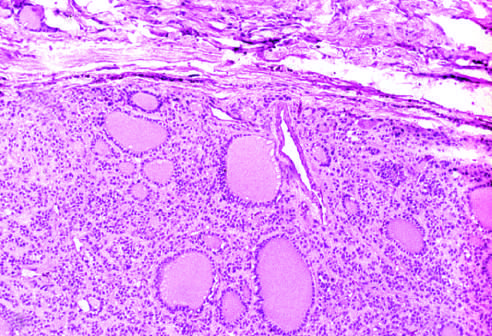does a fibrous capsule surround the neoplastic follicles?
Answer the question using a single word or phrase. Yes 